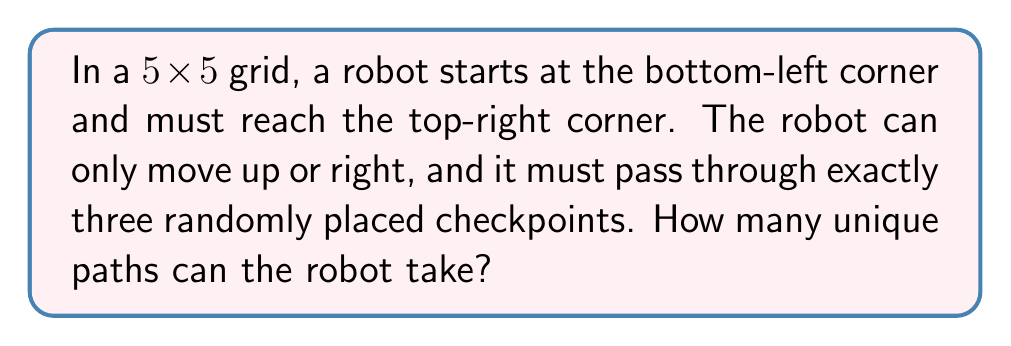Give your solution to this math problem. Let's approach this step-by-step:

1) First, we need to consider the total number of steps the robot must take. In a 5x5 grid, to get from bottom-left to top-right, the robot must take 4 steps right and 4 steps up, for a total of 8 steps.

2) Now, let's consider the checkpoints. We need to choose 3 positions out of the 7 internal points (excluding start and end) for the checkpoints. This can be done in $\binom{7}{3}$ ways.

3) For each checkpoint arrangement, we need to calculate the number of paths. We can break this down into four segments: start to first checkpoint, first to second checkpoint, second to third checkpoint, and third checkpoint to end.

4) For each segment, we can use the formula for paths in a grid: $\binom{x+y}{x}$ where x and y are the horizontal and vertical distances.

5) The total number of paths for a given checkpoint arrangement will be the product of the paths in each segment.

6) Finally, we sum this product over all possible checkpoint arrangements.

7) This can be expressed mathematically as:

   $$\sum_{(i,j,k,l,m,n,p,q)} \binom{i+j}{i} \binom{k+l}{k} \binom{m+n}{m} \binom{p+q}{p}$$

   where $(i,j)$, $(k,l)$, $(m,n)$, and $(p,q)$ are the coordinates of the three checkpoints and the end point, respectively.

8) Calculating this sum would be computationally intensive, but it gives us the exact number of unique paths.
Answer: $$\sum_{(i,j,k,l,m,n,p,q)} \binom{i+j}{i} \binom{k+l}{k} \binom{m+n}{m} \binom{p+q}{p}$$ 